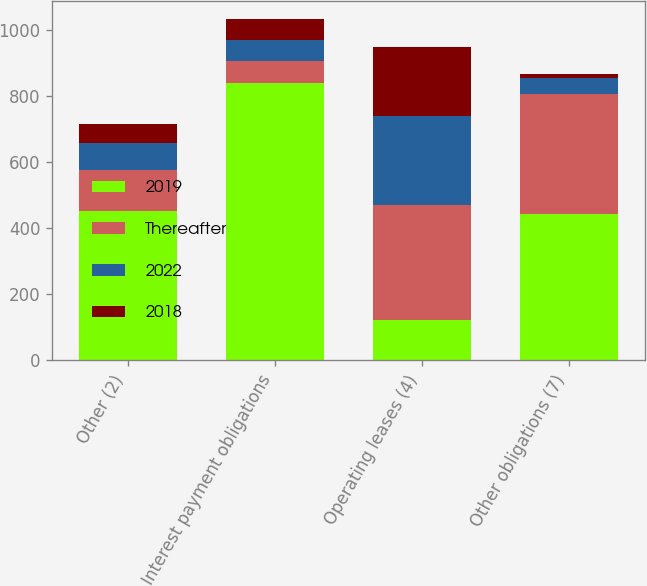Convert chart. <chart><loc_0><loc_0><loc_500><loc_500><stacked_bar_chart><ecel><fcel>Other (2)<fcel>Interest payment obligations<fcel>Operating leases (4)<fcel>Other obligations (7)<nl><fcel>2019<fcel>452<fcel>840<fcel>123<fcel>442<nl><fcel>Thereafter<fcel>123<fcel>65<fcel>346<fcel>365<nl><fcel>2022<fcel>82<fcel>65<fcel>272<fcel>48<nl><fcel>2018<fcel>59<fcel>65<fcel>207<fcel>12<nl></chart> 